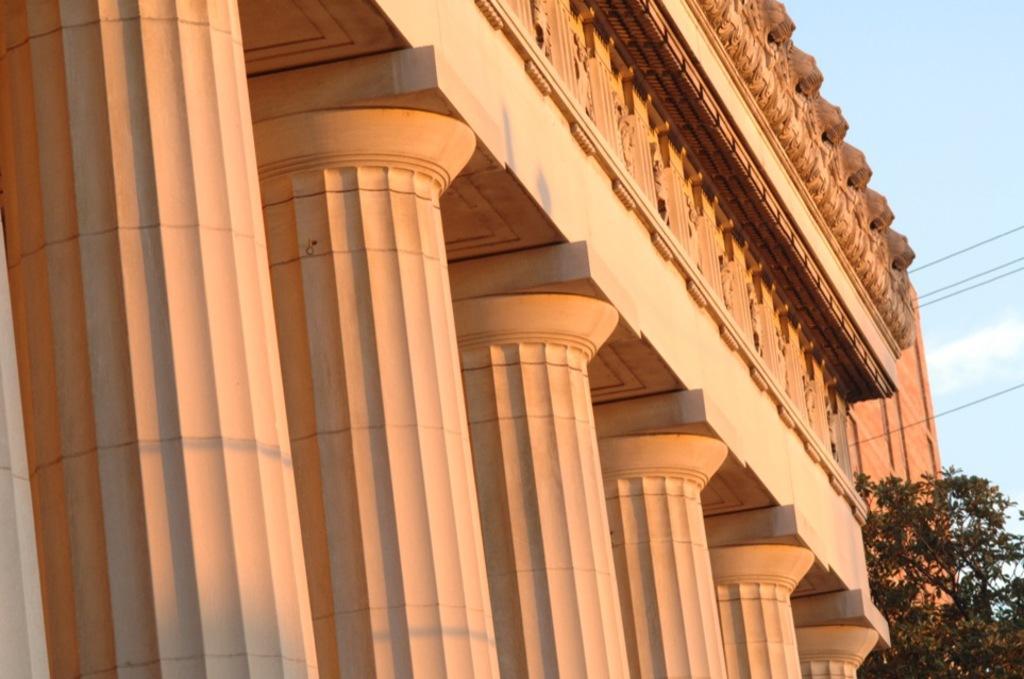In one or two sentences, can you explain what this image depicts? In this picture we can see a building, pillars and cables. On the right side of the building there is a tree and behind the building there is the sky. 